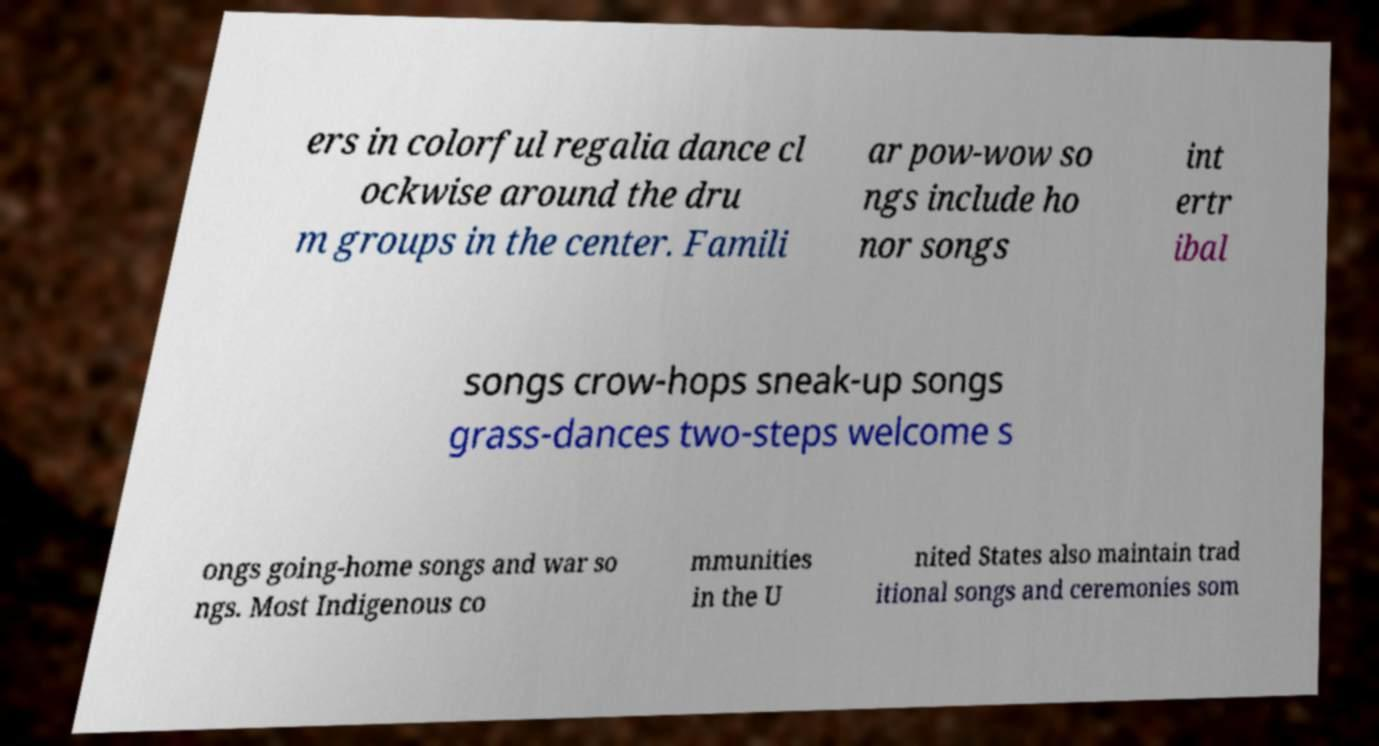I need the written content from this picture converted into text. Can you do that? ers in colorful regalia dance cl ockwise around the dru m groups in the center. Famili ar pow-wow so ngs include ho nor songs int ertr ibal songs crow-hops sneak-up songs grass-dances two-steps welcome s ongs going-home songs and war so ngs. Most Indigenous co mmunities in the U nited States also maintain trad itional songs and ceremonies som 